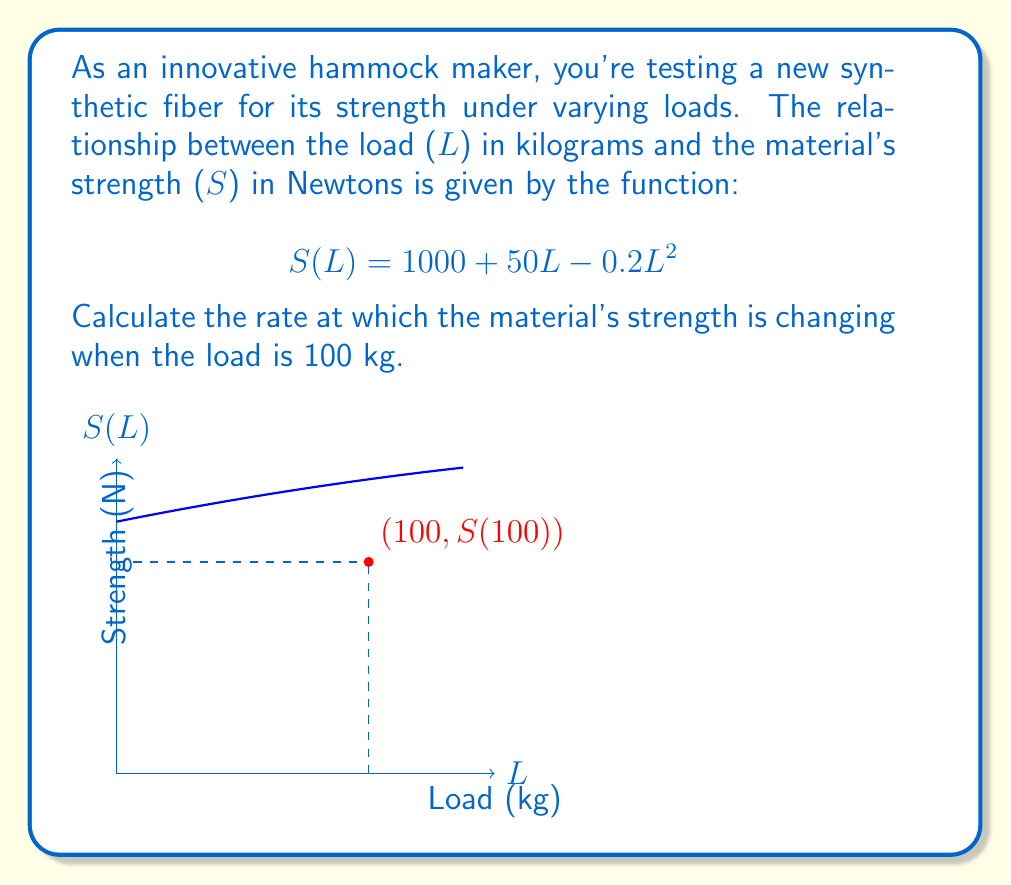What is the answer to this math problem? To find the rate at which the material's strength is changing when the load is 100 kg, we need to calculate the derivative of the strength function S(L) and evaluate it at L = 100.

Step 1: Find the derivative of S(L).
$$S(L) = 1000 + 50L - 0.2L^2$$
$$\frac{dS}{dL} = 50 - 0.4L$$

Step 2: Evaluate the derivative at L = 100.
$$\frac{dS}{dL}\bigg|_{L=100} = 50 - 0.4(100)$$
$$= 50 - 40$$
$$= 10$$

The rate of change is 10 Newtons per kilogram when the load is 100 kg.

Step 3: Interpret the result.
The positive value indicates that the material's strength is still increasing at this point, but at a slower rate compared to smaller loads. This suggests that the material is approaching its maximum strength capacity.
Answer: 10 N/kg 